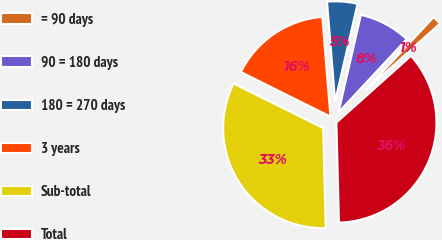Convert chart. <chart><loc_0><loc_0><loc_500><loc_500><pie_chart><fcel>= 90 days<fcel>90 = 180 days<fcel>180 = 270 days<fcel>3 years<fcel>Sub-total<fcel>Total<nl><fcel>1.45%<fcel>8.34%<fcel>4.89%<fcel>16.36%<fcel>32.76%<fcel>36.2%<nl></chart> 